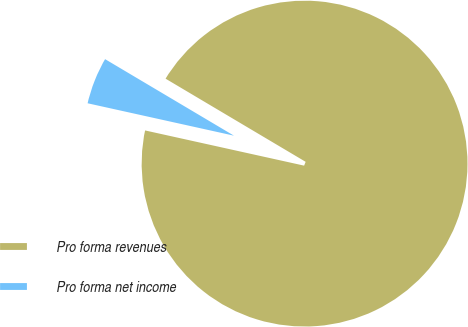Convert chart. <chart><loc_0><loc_0><loc_500><loc_500><pie_chart><fcel>Pro forma revenues<fcel>Pro forma net income<nl><fcel>94.94%<fcel>5.06%<nl></chart> 